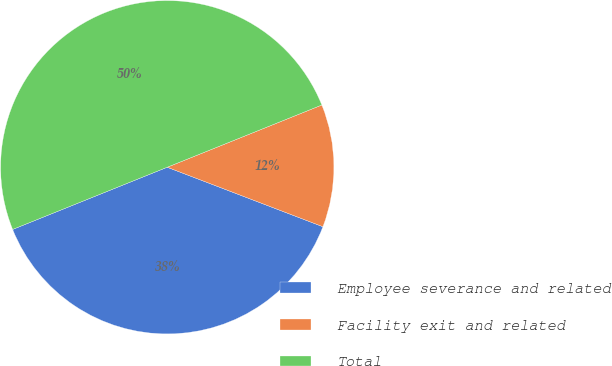Convert chart. <chart><loc_0><loc_0><loc_500><loc_500><pie_chart><fcel>Employee severance and related<fcel>Facility exit and related<fcel>Total<nl><fcel>38.1%<fcel>11.9%<fcel>50.0%<nl></chart> 